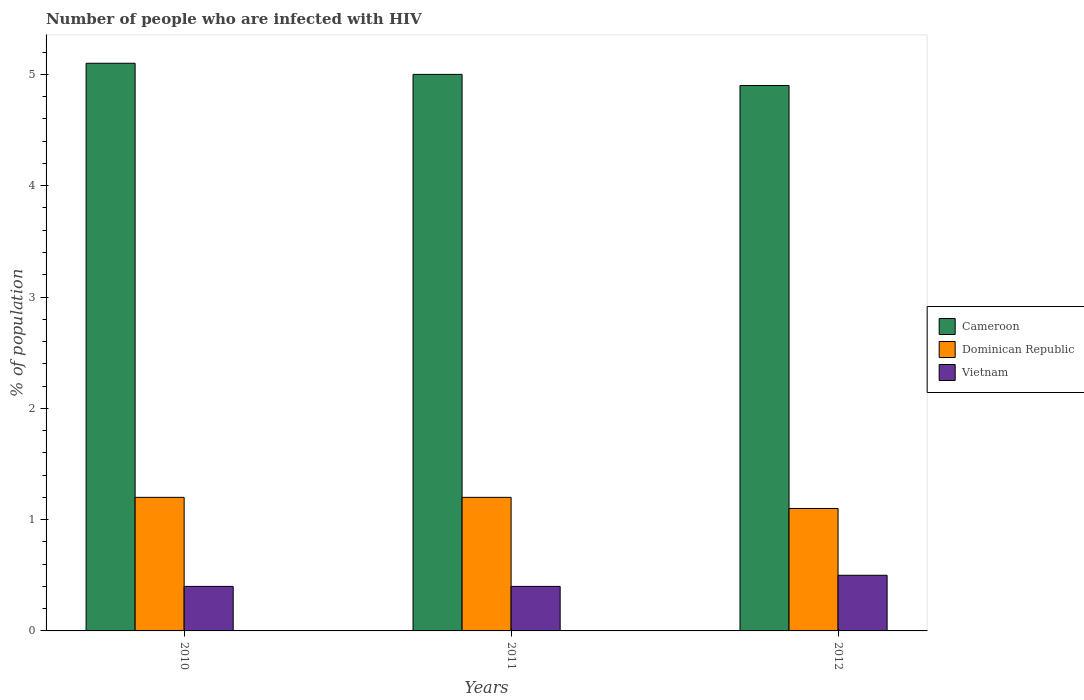How many bars are there on the 1st tick from the right?
Offer a very short reply. 3. What is the label of the 2nd group of bars from the left?
Give a very brief answer. 2011. What is the percentage of HIV infected population in in Vietnam in 2011?
Keep it short and to the point. 0.4. Across all years, what is the maximum percentage of HIV infected population in in Vietnam?
Provide a short and direct response. 0.5. In which year was the percentage of HIV infected population in in Dominican Republic maximum?
Provide a succinct answer. 2010. What is the total percentage of HIV infected population in in Dominican Republic in the graph?
Your answer should be compact. 3.5. What is the difference between the percentage of HIV infected population in in Dominican Republic in 2010 and that in 2012?
Offer a very short reply. 0.1. What is the difference between the percentage of HIV infected population in in Dominican Republic in 2011 and the percentage of HIV infected population in in Cameroon in 2010?
Give a very brief answer. -3.9. What is the average percentage of HIV infected population in in Cameroon per year?
Your answer should be very brief. 5. In the year 2012, what is the difference between the percentage of HIV infected population in in Cameroon and percentage of HIV infected population in in Dominican Republic?
Offer a very short reply. 3.8. In how many years, is the percentage of HIV infected population in in Vietnam greater than 1.2 %?
Keep it short and to the point. 0. Is the difference between the percentage of HIV infected population in in Cameroon in 2011 and 2012 greater than the difference between the percentage of HIV infected population in in Dominican Republic in 2011 and 2012?
Your answer should be very brief. No. What is the difference between the highest and the second highest percentage of HIV infected population in in Cameroon?
Ensure brevity in your answer.  0.1. What is the difference between the highest and the lowest percentage of HIV infected population in in Dominican Republic?
Give a very brief answer. 0.1. In how many years, is the percentage of HIV infected population in in Cameroon greater than the average percentage of HIV infected population in in Cameroon taken over all years?
Offer a very short reply. 1. What does the 1st bar from the left in 2012 represents?
Ensure brevity in your answer.  Cameroon. What does the 2nd bar from the right in 2010 represents?
Provide a succinct answer. Dominican Republic. What is the difference between two consecutive major ticks on the Y-axis?
Give a very brief answer. 1. Does the graph contain any zero values?
Ensure brevity in your answer.  No. How are the legend labels stacked?
Ensure brevity in your answer.  Vertical. What is the title of the graph?
Provide a succinct answer. Number of people who are infected with HIV. Does "Nigeria" appear as one of the legend labels in the graph?
Make the answer very short. No. What is the label or title of the X-axis?
Ensure brevity in your answer.  Years. What is the label or title of the Y-axis?
Offer a terse response. % of population. What is the % of population of Vietnam in 2010?
Your response must be concise. 0.4. What is the % of population of Cameroon in 2011?
Provide a succinct answer. 5. What is the % of population of Dominican Republic in 2012?
Keep it short and to the point. 1.1. What is the % of population of Vietnam in 2012?
Ensure brevity in your answer.  0.5. Across all years, what is the maximum % of population of Dominican Republic?
Make the answer very short. 1.2. Across all years, what is the maximum % of population of Vietnam?
Your answer should be compact. 0.5. Across all years, what is the minimum % of population in Dominican Republic?
Provide a short and direct response. 1.1. What is the total % of population in Cameroon in the graph?
Provide a succinct answer. 15. What is the total % of population of Vietnam in the graph?
Your answer should be very brief. 1.3. What is the difference between the % of population of Cameroon in 2010 and that in 2011?
Keep it short and to the point. 0.1. What is the difference between the % of population of Dominican Republic in 2010 and that in 2011?
Your answer should be very brief. 0. What is the difference between the % of population in Vietnam in 2010 and that in 2012?
Make the answer very short. -0.1. What is the difference between the % of population in Dominican Republic in 2011 and that in 2012?
Give a very brief answer. 0.1. What is the difference between the % of population of Vietnam in 2011 and that in 2012?
Offer a very short reply. -0.1. What is the difference between the % of population in Cameroon in 2010 and the % of population in Dominican Republic in 2011?
Provide a short and direct response. 3.9. What is the difference between the % of population of Cameroon in 2010 and the % of population of Vietnam in 2011?
Ensure brevity in your answer.  4.7. What is the difference between the % of population of Cameroon in 2011 and the % of population of Vietnam in 2012?
Offer a terse response. 4.5. What is the average % of population in Dominican Republic per year?
Your answer should be compact. 1.17. What is the average % of population of Vietnam per year?
Provide a short and direct response. 0.43. In the year 2010, what is the difference between the % of population of Cameroon and % of population of Dominican Republic?
Give a very brief answer. 3.9. In the year 2010, what is the difference between the % of population of Dominican Republic and % of population of Vietnam?
Offer a very short reply. 0.8. In the year 2011, what is the difference between the % of population of Cameroon and % of population of Dominican Republic?
Offer a terse response. 3.8. In the year 2011, what is the difference between the % of population of Cameroon and % of population of Vietnam?
Ensure brevity in your answer.  4.6. In the year 2011, what is the difference between the % of population of Dominican Republic and % of population of Vietnam?
Make the answer very short. 0.8. In the year 2012, what is the difference between the % of population in Cameroon and % of population in Vietnam?
Provide a succinct answer. 4.4. In the year 2012, what is the difference between the % of population in Dominican Republic and % of population in Vietnam?
Keep it short and to the point. 0.6. What is the ratio of the % of population of Dominican Republic in 2010 to that in 2011?
Offer a very short reply. 1. What is the ratio of the % of population of Vietnam in 2010 to that in 2011?
Give a very brief answer. 1. What is the ratio of the % of population in Cameroon in 2010 to that in 2012?
Provide a succinct answer. 1.04. What is the ratio of the % of population of Vietnam in 2010 to that in 2012?
Your answer should be very brief. 0.8. What is the ratio of the % of population of Cameroon in 2011 to that in 2012?
Your answer should be very brief. 1.02. What is the ratio of the % of population of Vietnam in 2011 to that in 2012?
Make the answer very short. 0.8. What is the difference between the highest and the second highest % of population of Cameroon?
Provide a short and direct response. 0.1. What is the difference between the highest and the second highest % of population in Dominican Republic?
Ensure brevity in your answer.  0. What is the difference between the highest and the second highest % of population of Vietnam?
Keep it short and to the point. 0.1. What is the difference between the highest and the lowest % of population in Vietnam?
Make the answer very short. 0.1. 